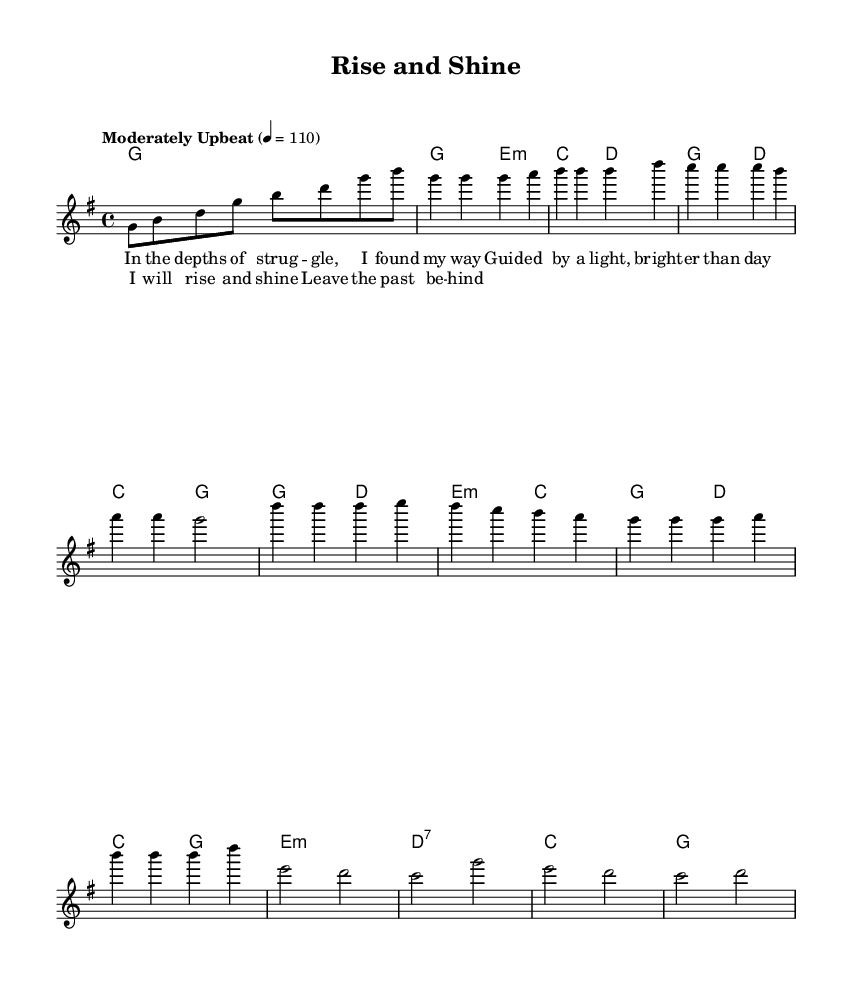What is the key signature of this music? The key signature indicates the tonality of the piece. In this sheet music, the key signature shows one sharp, which corresponds to the key of G major.
Answer: G major What is the time signature of this music? The time signature is found at the beginning of the sheet music and indicates how many beats are in each measure. Here, the time signature is four beats per measure, indicated as 4/4.
Answer: 4/4 What is the tempo marking for this piece? The tempo marking, which indicates the speed of the music, is located at the beginning of the score. It states "Moderately Upbeat" with a metronome marking of 110 beats per minute.
Answer: Moderately Upbeat How many measures are in the verse section? To find the number of measures in the verse section, we count the individual measures indicated in the melody and harmonies for the verse. There are four measures in the verse section.
Answer: 4 What is the main theme of the chorus lyrics? The main theme can be derived from the lyrics of the chorus, which focuses on a positive affirmation of rising and leaving the past behind. This thematic expression of personal growth is central to the message.
Answer: Rising and leaving the past behind Which chord is used in the first measure of the harmony? The chord in the first measure corresponds to the introduction of the piece. It is a G major chord, as indicated by the notation in the harmony section.
Answer: G What type of song structure is used in this music? The song structure is identified by examining how the sections are organized. In this piece, it follows the typical structure of verse-chorus-bridge, which is common in gospel music.
Answer: Verse-chorus-bridge 